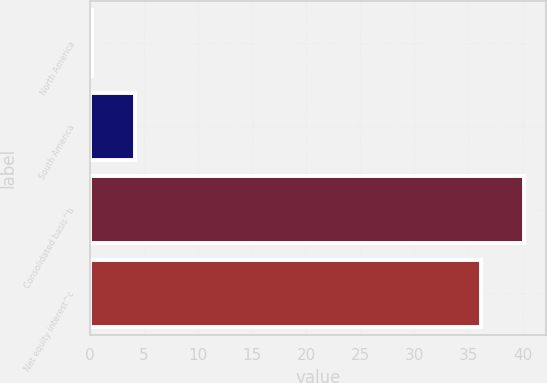<chart> <loc_0><loc_0><loc_500><loc_500><bar_chart><fcel>North America<fcel>South America<fcel>Consolidated basis^b<fcel>Net equity interest^c<nl><fcel>0.2<fcel>4.18<fcel>40.18<fcel>36.2<nl></chart> 